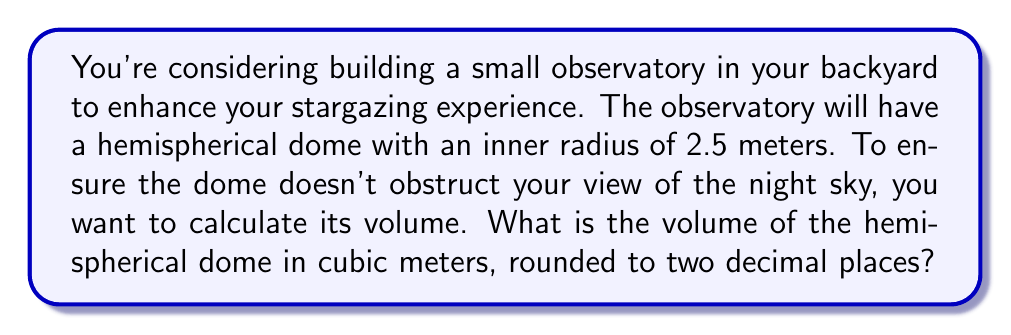What is the answer to this math problem? To solve this problem, we need to follow these steps:

1) The formula for the volume of a hemisphere is:

   $$V = \frac{2}{3}\pi r^3$$

   Where $r$ is the radius of the hemisphere.

2) We are given that the inner radius of the dome is 2.5 meters.

3) Let's substitute this into our formula:

   $$V = \frac{2}{3}\pi (2.5)^3$$

4) Now, let's calculate step by step:
   
   $$V = \frac{2}{3}\pi (15.625)$$
   
   $$V = 10.4166667\pi$$

5) Using $\pi \approx 3.14159$, we get:

   $$V \approx 10.4166667 * 3.14159 = 32.7249$$

6) Rounding to two decimal places:

   $$V \approx 32.72 \text{ cubic meters}$$

[asy]
import three;

size(200);
currentprojection=perspective(6,3,2);

draw(surface(sphere((0,0,0),2.5)),lightgray);
draw(scale(2.5)*unitcircle3, blue);
draw((0,0,0)--(2.5,0,0),red,Arrow3);

label("r = 2.5m", (1.25,0,0), N);
[/asy]
Answer: The volume of the hemispherical dome is approximately 32.72 cubic meters. 